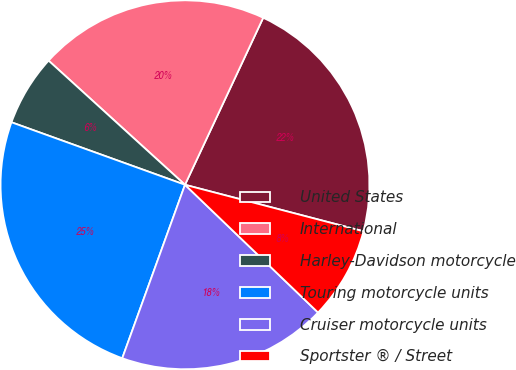Convert chart. <chart><loc_0><loc_0><loc_500><loc_500><pie_chart><fcel>United States<fcel>International<fcel>Harley-Davidson motorcycle<fcel>Touring motorcycle units<fcel>Cruiser motorcycle units<fcel>Sportster ® / Street<nl><fcel>22.09%<fcel>20.22%<fcel>6.25%<fcel>24.98%<fcel>18.35%<fcel>8.12%<nl></chart> 